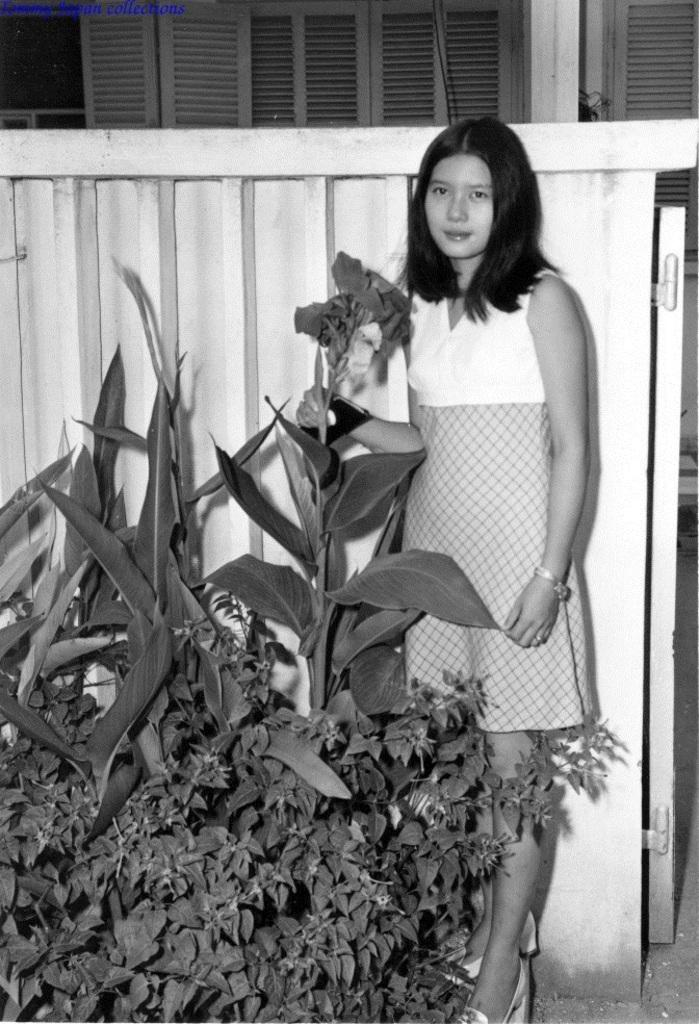What is the color scheme of the image? The image is black and white. What can be seen in the foreground of the image? There are plants and a woman in the foreground of the image. What is visible in the background of the image? There is a wall and a construction site in the background of the image. How many years of experience does the beginner have in the image? There is no mention of a beginner or any experience level in the image. 